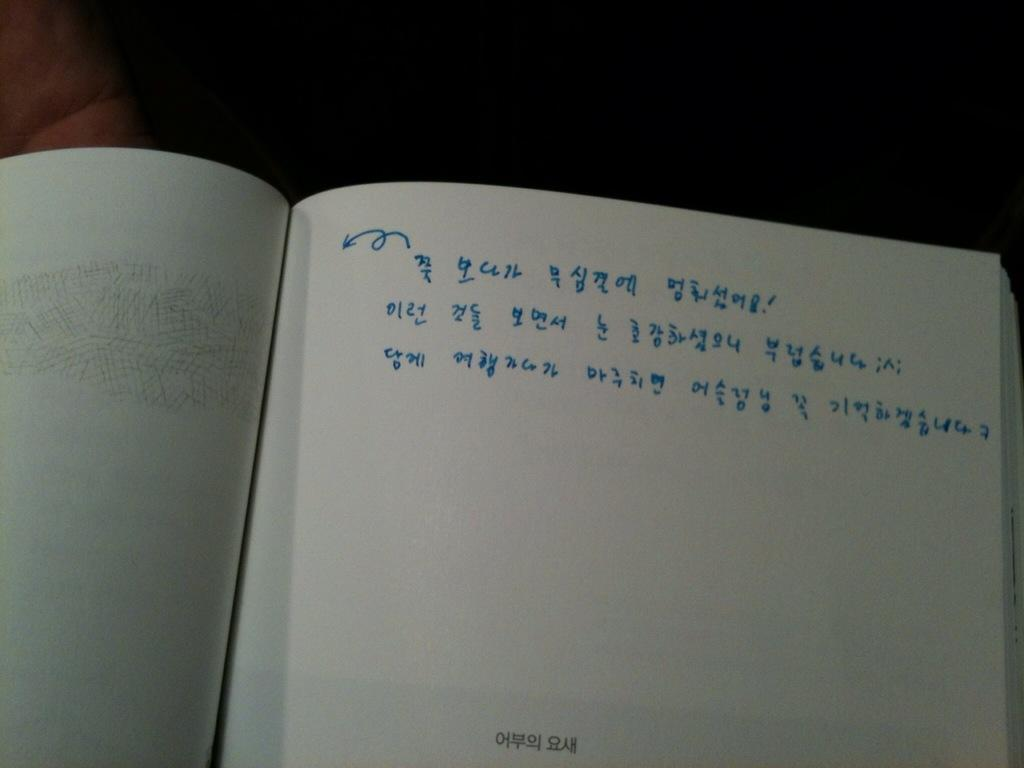<image>
Provide a brief description of the given image. A small bit of Asian writing is the only other writing on a page half filled with blue numbers. 